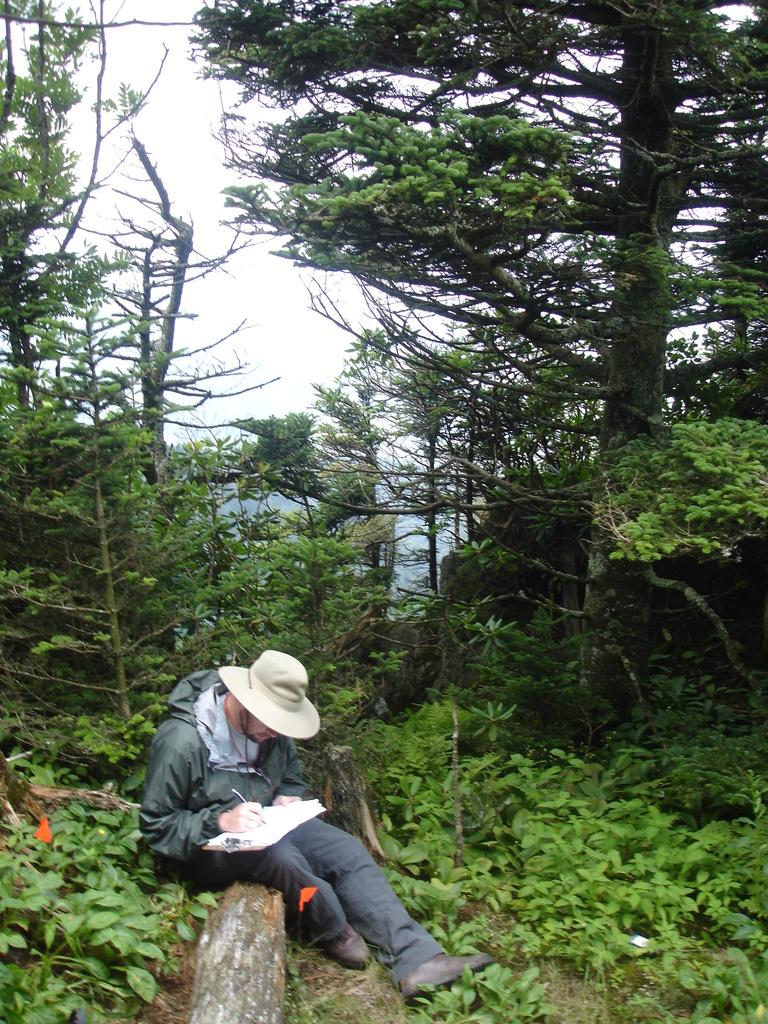What is the main subject of the image? There is a person in the image. Can you describe the person's attire? The person is wearing a hat, a jacket, and shoes. What objects is the person holding? The person is holding a pad and a pen. What is the person's posture in the image? The person is sitting. What can be seen in the background of the image? There are plants, trees, and the sky visible in the background. What type of copper material is being used to create the route in the image? There is no copper or route present in the image. What type of linen fabric is draped over the person's chair in the image? There is no linen fabric or chair visible in the image. 